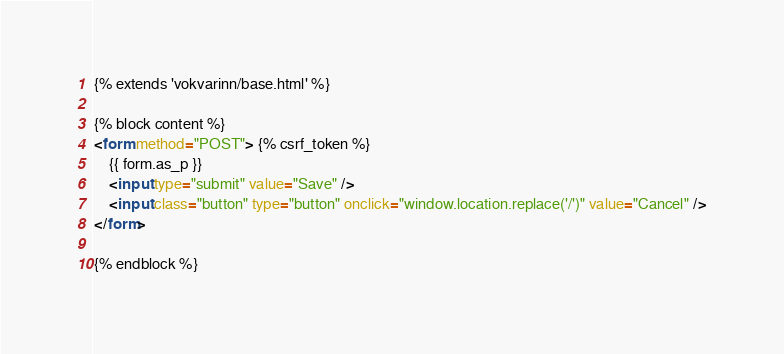<code> <loc_0><loc_0><loc_500><loc_500><_HTML_>{% extends 'vokvarinn/base.html' %}

{% block content %}
<form method="POST"> {% csrf_token %}
    {{ form.as_p }}
    <input type="submit" value="Save" />
    <input class="button" type="button" onclick="window.location.replace('/')" value="Cancel" />
</form>

{% endblock %}</code> 